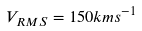Convert formula to latex. <formula><loc_0><loc_0><loc_500><loc_500>V _ { R M S } = 1 5 0 k m s ^ { - 1 }</formula> 